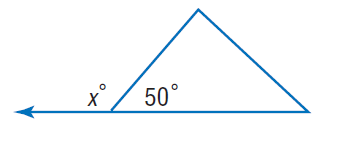Question: Find x.
Choices:
A. 40
B. 50
C. 130
D. 310
Answer with the letter. Answer: C 